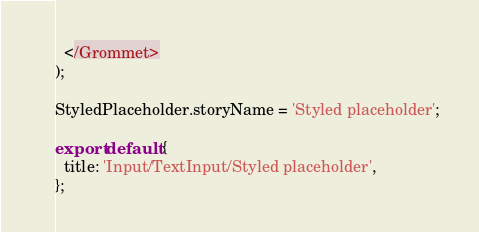Convert code to text. <code><loc_0><loc_0><loc_500><loc_500><_JavaScript_>  </Grommet>
);

StyledPlaceholder.storyName = 'Styled placeholder';

export default {
  title: 'Input/TextInput/Styled placeholder',
};
</code> 